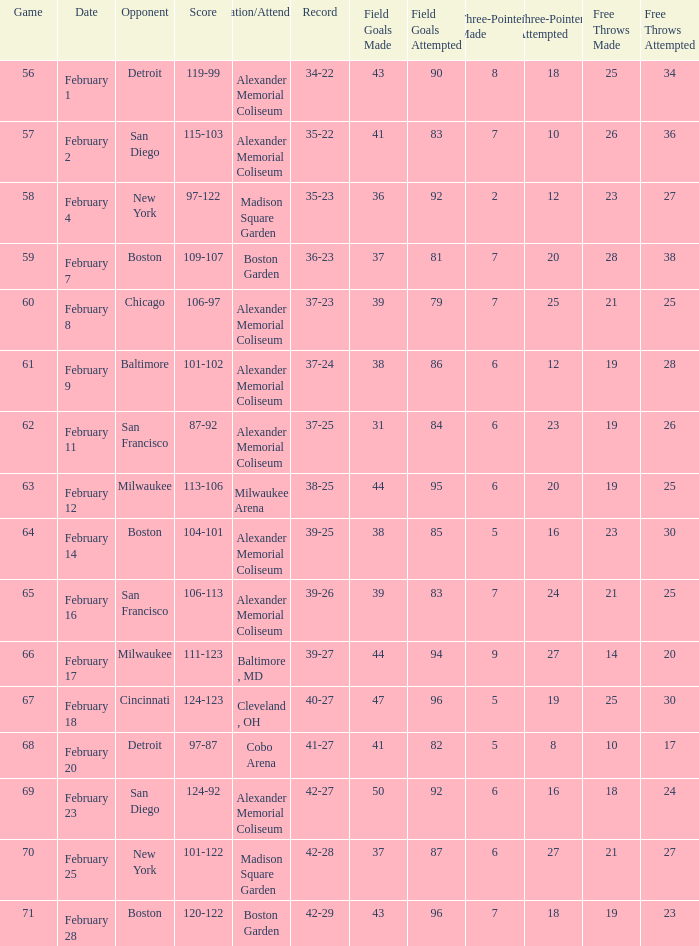What is the Game # that scored 87-92? 62.0. 